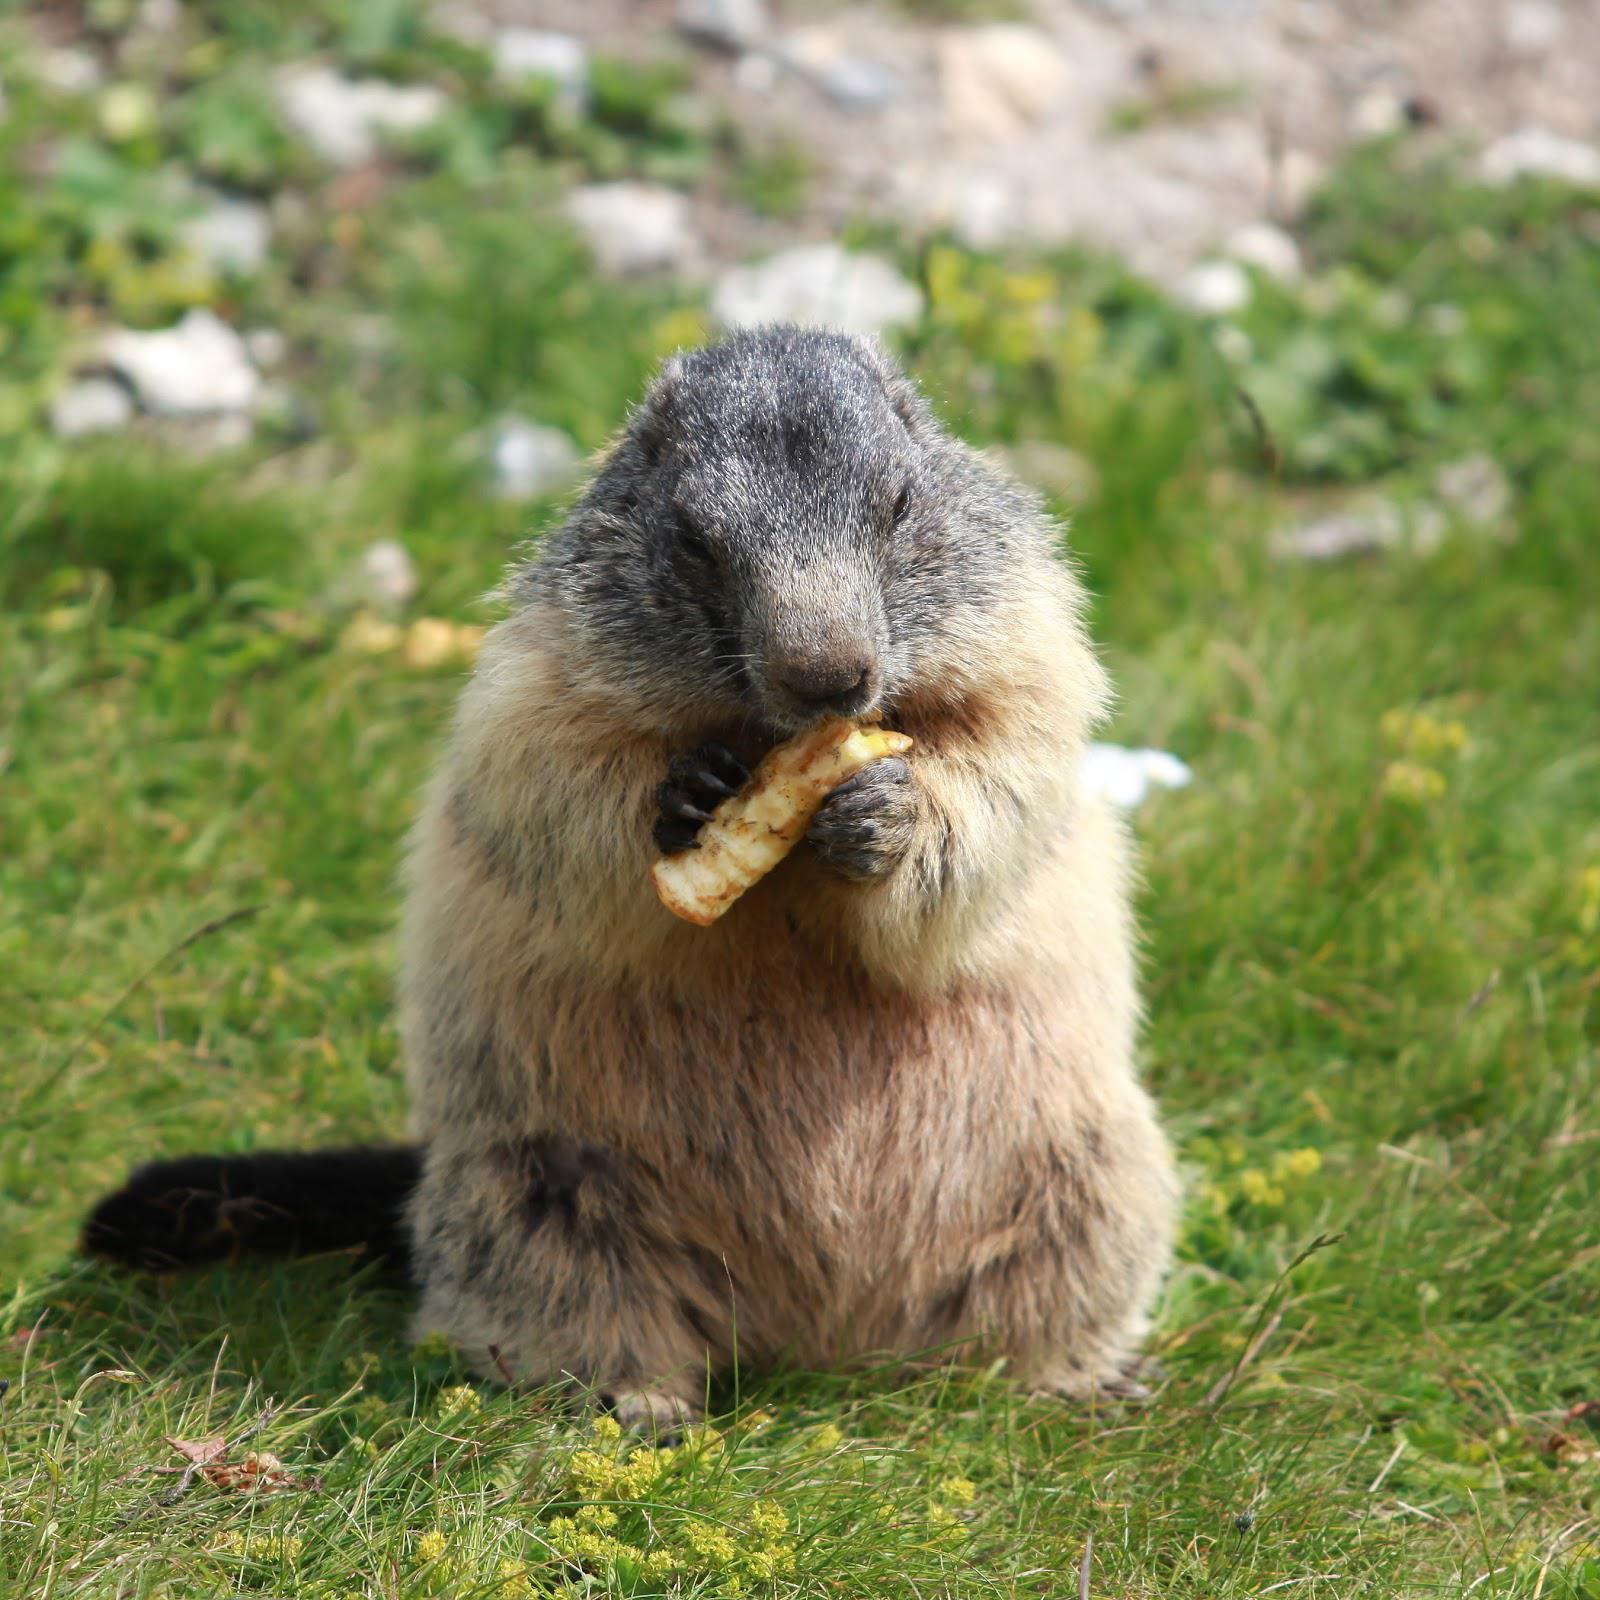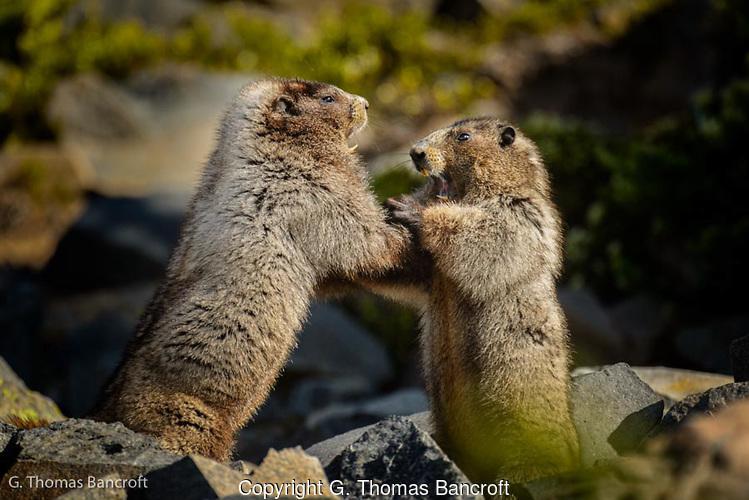The first image is the image on the left, the second image is the image on the right. Examine the images to the left and right. Is the description "The left image contains exactly one rodent standing on grass." accurate? Answer yes or no. Yes. The first image is the image on the left, the second image is the image on the right. Examine the images to the left and right. Is the description "An image contains one marmot, which stands upright in green grass with its body turned to the camera." accurate? Answer yes or no. Yes. 